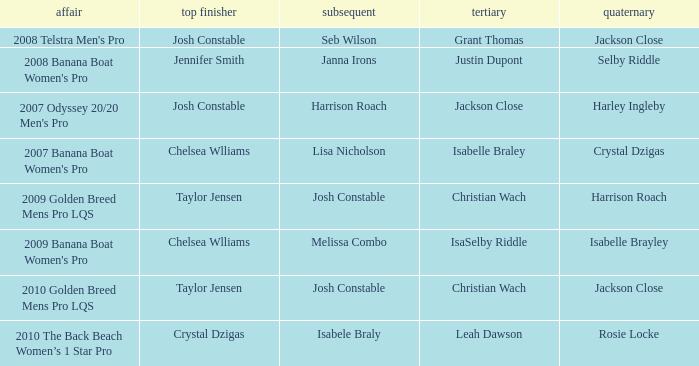Who was the Winner when Selby Riddle came in Fourth? Jennifer Smith. 